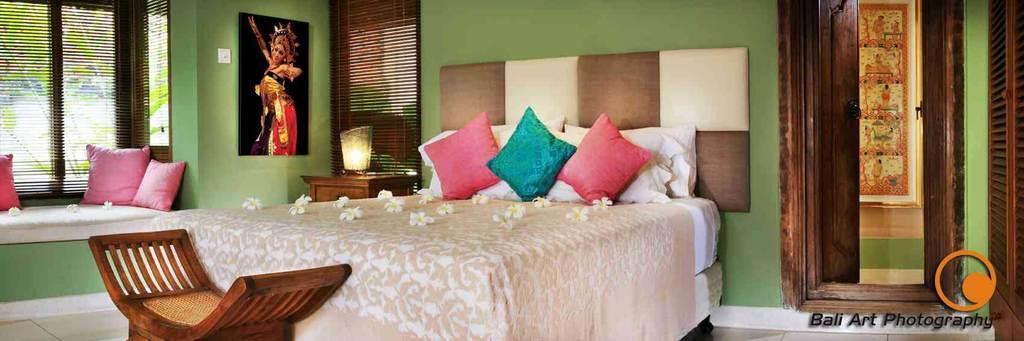How would you summarize this image in a sentence or two? The picture is taken in a room. In the center of the picture there is a bed, on the bed there are flowers, pillow and blanket. On the right there are doors. On the left there is a couch, on the couch there are pillows, flowers and windows. In the center of the background there are frame, lamp, desk and window. On the left, outside the window there are trees. In the foreground there is a chair. 